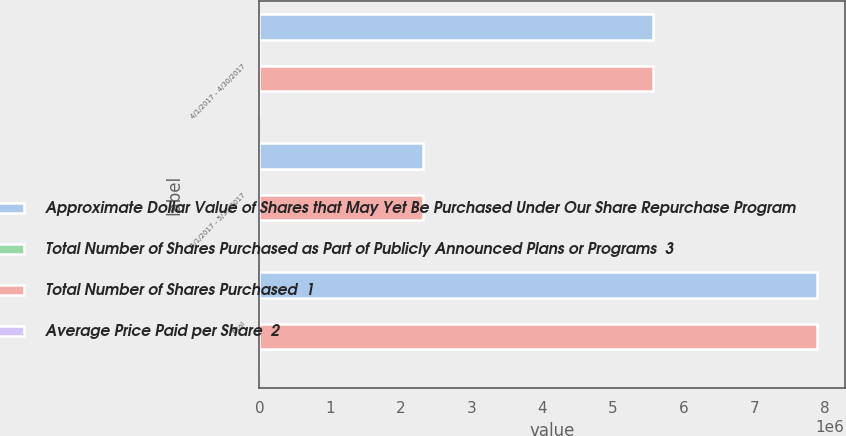Convert chart to OTSL. <chart><loc_0><loc_0><loc_500><loc_500><stacked_bar_chart><ecel><fcel>4/1/2017 - 4/30/2017<fcel>5/1/2017 - 5/31/2017<fcel>Total<nl><fcel>Approximate Dollar Value of Shares that May Yet Be Purchased Under Our Share Repurchase Program<fcel>5.56804e+06<fcel>2.31504e+06<fcel>7.88307e+06<nl><fcel>Total Number of Shares Purchased as Part of Publicly Announced Plans or Programs  3<fcel>89.8<fcel>86.39<fcel>88.8<nl><fcel>Total Number of Shares Purchased  1<fcel>5.56804e+06<fcel>2.31504e+06<fcel>7.88307e+06<nl><fcel>Average Price Paid per Share  2<fcel>3<fcel>3<fcel>3<nl></chart> 